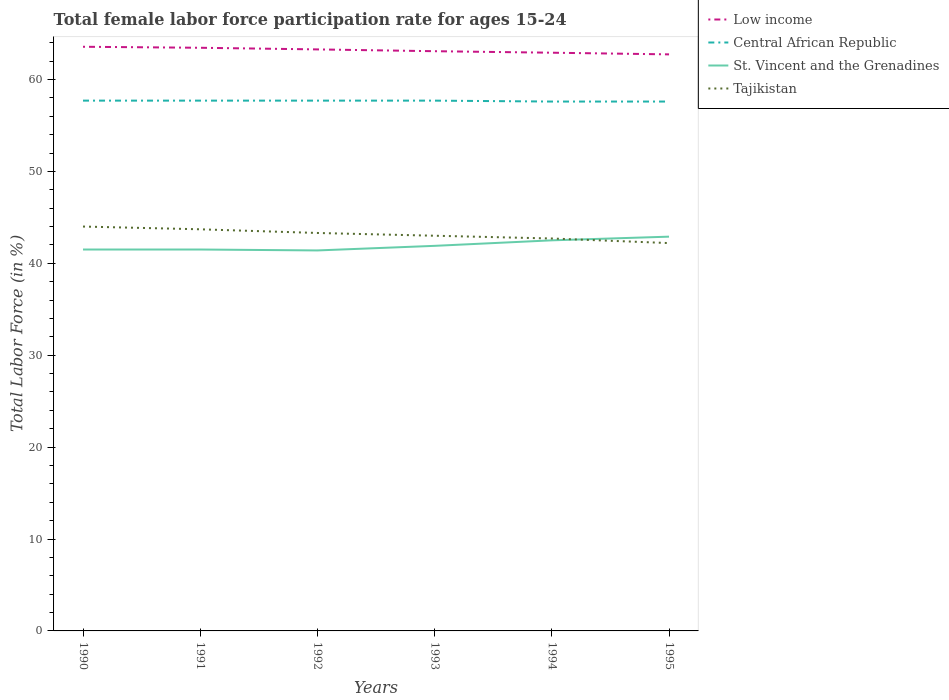How many different coloured lines are there?
Your answer should be compact. 4. Does the line corresponding to Tajikistan intersect with the line corresponding to Central African Republic?
Make the answer very short. No. Is the number of lines equal to the number of legend labels?
Your answer should be compact. Yes. Across all years, what is the maximum female labor force participation rate in Tajikistan?
Offer a terse response. 42.2. What is the difference between the highest and the lowest female labor force participation rate in St. Vincent and the Grenadines?
Provide a succinct answer. 2. Is the female labor force participation rate in St. Vincent and the Grenadines strictly greater than the female labor force participation rate in Tajikistan over the years?
Your answer should be compact. No. How many lines are there?
Offer a terse response. 4. How many years are there in the graph?
Make the answer very short. 6. What is the difference between two consecutive major ticks on the Y-axis?
Your response must be concise. 10. How are the legend labels stacked?
Your response must be concise. Vertical. What is the title of the graph?
Offer a terse response. Total female labor force participation rate for ages 15-24. What is the label or title of the Y-axis?
Ensure brevity in your answer.  Total Labor Force (in %). What is the Total Labor Force (in %) in Low income in 1990?
Your answer should be compact. 63.56. What is the Total Labor Force (in %) in Central African Republic in 1990?
Your answer should be very brief. 57.7. What is the Total Labor Force (in %) of St. Vincent and the Grenadines in 1990?
Offer a terse response. 41.5. What is the Total Labor Force (in %) of Tajikistan in 1990?
Offer a very short reply. 44. What is the Total Labor Force (in %) in Low income in 1991?
Ensure brevity in your answer.  63.45. What is the Total Labor Force (in %) in Central African Republic in 1991?
Ensure brevity in your answer.  57.7. What is the Total Labor Force (in %) of St. Vincent and the Grenadines in 1991?
Your answer should be very brief. 41.5. What is the Total Labor Force (in %) of Tajikistan in 1991?
Ensure brevity in your answer.  43.7. What is the Total Labor Force (in %) in Low income in 1992?
Offer a terse response. 63.27. What is the Total Labor Force (in %) of Central African Republic in 1992?
Make the answer very short. 57.7. What is the Total Labor Force (in %) in St. Vincent and the Grenadines in 1992?
Your answer should be compact. 41.4. What is the Total Labor Force (in %) of Tajikistan in 1992?
Keep it short and to the point. 43.3. What is the Total Labor Force (in %) in Low income in 1993?
Keep it short and to the point. 63.08. What is the Total Labor Force (in %) in Central African Republic in 1993?
Keep it short and to the point. 57.7. What is the Total Labor Force (in %) of St. Vincent and the Grenadines in 1993?
Your answer should be compact. 41.9. What is the Total Labor Force (in %) in Low income in 1994?
Provide a succinct answer. 62.91. What is the Total Labor Force (in %) of Central African Republic in 1994?
Keep it short and to the point. 57.6. What is the Total Labor Force (in %) of St. Vincent and the Grenadines in 1994?
Your answer should be compact. 42.5. What is the Total Labor Force (in %) of Tajikistan in 1994?
Keep it short and to the point. 42.7. What is the Total Labor Force (in %) of Low income in 1995?
Your answer should be very brief. 62.73. What is the Total Labor Force (in %) of Central African Republic in 1995?
Offer a very short reply. 57.6. What is the Total Labor Force (in %) of St. Vincent and the Grenadines in 1995?
Your answer should be very brief. 42.9. What is the Total Labor Force (in %) in Tajikistan in 1995?
Keep it short and to the point. 42.2. Across all years, what is the maximum Total Labor Force (in %) of Low income?
Provide a succinct answer. 63.56. Across all years, what is the maximum Total Labor Force (in %) of Central African Republic?
Provide a succinct answer. 57.7. Across all years, what is the maximum Total Labor Force (in %) in St. Vincent and the Grenadines?
Your answer should be very brief. 42.9. Across all years, what is the maximum Total Labor Force (in %) in Tajikistan?
Offer a very short reply. 44. Across all years, what is the minimum Total Labor Force (in %) of Low income?
Provide a succinct answer. 62.73. Across all years, what is the minimum Total Labor Force (in %) of Central African Republic?
Ensure brevity in your answer.  57.6. Across all years, what is the minimum Total Labor Force (in %) of St. Vincent and the Grenadines?
Offer a terse response. 41.4. Across all years, what is the minimum Total Labor Force (in %) of Tajikistan?
Make the answer very short. 42.2. What is the total Total Labor Force (in %) of Low income in the graph?
Your answer should be compact. 379.01. What is the total Total Labor Force (in %) of Central African Republic in the graph?
Your answer should be very brief. 346. What is the total Total Labor Force (in %) in St. Vincent and the Grenadines in the graph?
Your answer should be compact. 251.7. What is the total Total Labor Force (in %) of Tajikistan in the graph?
Provide a succinct answer. 258.9. What is the difference between the Total Labor Force (in %) in Low income in 1990 and that in 1991?
Give a very brief answer. 0.11. What is the difference between the Total Labor Force (in %) in St. Vincent and the Grenadines in 1990 and that in 1991?
Ensure brevity in your answer.  0. What is the difference between the Total Labor Force (in %) in Tajikistan in 1990 and that in 1991?
Provide a short and direct response. 0.3. What is the difference between the Total Labor Force (in %) in Low income in 1990 and that in 1992?
Keep it short and to the point. 0.29. What is the difference between the Total Labor Force (in %) of Central African Republic in 1990 and that in 1992?
Your answer should be very brief. 0. What is the difference between the Total Labor Force (in %) in Low income in 1990 and that in 1993?
Keep it short and to the point. 0.48. What is the difference between the Total Labor Force (in %) of Tajikistan in 1990 and that in 1993?
Provide a succinct answer. 1. What is the difference between the Total Labor Force (in %) in Low income in 1990 and that in 1994?
Your answer should be compact. 0.65. What is the difference between the Total Labor Force (in %) of St. Vincent and the Grenadines in 1990 and that in 1994?
Offer a terse response. -1. What is the difference between the Total Labor Force (in %) of Tajikistan in 1990 and that in 1994?
Your answer should be compact. 1.3. What is the difference between the Total Labor Force (in %) in Low income in 1990 and that in 1995?
Ensure brevity in your answer.  0.83. What is the difference between the Total Labor Force (in %) of Central African Republic in 1990 and that in 1995?
Offer a very short reply. 0.1. What is the difference between the Total Labor Force (in %) in St. Vincent and the Grenadines in 1990 and that in 1995?
Give a very brief answer. -1.4. What is the difference between the Total Labor Force (in %) in Low income in 1991 and that in 1992?
Your answer should be compact. 0.18. What is the difference between the Total Labor Force (in %) of Central African Republic in 1991 and that in 1992?
Your answer should be compact. 0. What is the difference between the Total Labor Force (in %) of St. Vincent and the Grenadines in 1991 and that in 1992?
Give a very brief answer. 0.1. What is the difference between the Total Labor Force (in %) in Tajikistan in 1991 and that in 1992?
Provide a short and direct response. 0.4. What is the difference between the Total Labor Force (in %) in Low income in 1991 and that in 1993?
Ensure brevity in your answer.  0.37. What is the difference between the Total Labor Force (in %) in Low income in 1991 and that in 1994?
Make the answer very short. 0.54. What is the difference between the Total Labor Force (in %) in Tajikistan in 1991 and that in 1994?
Keep it short and to the point. 1. What is the difference between the Total Labor Force (in %) in Low income in 1991 and that in 1995?
Ensure brevity in your answer.  0.72. What is the difference between the Total Labor Force (in %) in Central African Republic in 1991 and that in 1995?
Provide a succinct answer. 0.1. What is the difference between the Total Labor Force (in %) of Low income in 1992 and that in 1993?
Offer a terse response. 0.2. What is the difference between the Total Labor Force (in %) of Central African Republic in 1992 and that in 1993?
Keep it short and to the point. 0. What is the difference between the Total Labor Force (in %) of Low income in 1992 and that in 1994?
Your response must be concise. 0.36. What is the difference between the Total Labor Force (in %) in Central African Republic in 1992 and that in 1994?
Offer a very short reply. 0.1. What is the difference between the Total Labor Force (in %) in St. Vincent and the Grenadines in 1992 and that in 1994?
Provide a short and direct response. -1.1. What is the difference between the Total Labor Force (in %) in Tajikistan in 1992 and that in 1994?
Ensure brevity in your answer.  0.6. What is the difference between the Total Labor Force (in %) of Low income in 1992 and that in 1995?
Ensure brevity in your answer.  0.54. What is the difference between the Total Labor Force (in %) of St. Vincent and the Grenadines in 1992 and that in 1995?
Make the answer very short. -1.5. What is the difference between the Total Labor Force (in %) in Tajikistan in 1992 and that in 1995?
Ensure brevity in your answer.  1.1. What is the difference between the Total Labor Force (in %) in Low income in 1993 and that in 1994?
Keep it short and to the point. 0.16. What is the difference between the Total Labor Force (in %) in Central African Republic in 1993 and that in 1994?
Your response must be concise. 0.1. What is the difference between the Total Labor Force (in %) in St. Vincent and the Grenadines in 1993 and that in 1994?
Offer a terse response. -0.6. What is the difference between the Total Labor Force (in %) of Low income in 1993 and that in 1995?
Keep it short and to the point. 0.34. What is the difference between the Total Labor Force (in %) in Tajikistan in 1993 and that in 1995?
Offer a terse response. 0.8. What is the difference between the Total Labor Force (in %) of Low income in 1994 and that in 1995?
Provide a succinct answer. 0.18. What is the difference between the Total Labor Force (in %) of St. Vincent and the Grenadines in 1994 and that in 1995?
Keep it short and to the point. -0.4. What is the difference between the Total Labor Force (in %) in Low income in 1990 and the Total Labor Force (in %) in Central African Republic in 1991?
Keep it short and to the point. 5.86. What is the difference between the Total Labor Force (in %) in Low income in 1990 and the Total Labor Force (in %) in St. Vincent and the Grenadines in 1991?
Offer a terse response. 22.06. What is the difference between the Total Labor Force (in %) in Low income in 1990 and the Total Labor Force (in %) in Tajikistan in 1991?
Offer a terse response. 19.86. What is the difference between the Total Labor Force (in %) of Central African Republic in 1990 and the Total Labor Force (in %) of St. Vincent and the Grenadines in 1991?
Offer a terse response. 16.2. What is the difference between the Total Labor Force (in %) of Central African Republic in 1990 and the Total Labor Force (in %) of Tajikistan in 1991?
Offer a terse response. 14. What is the difference between the Total Labor Force (in %) in St. Vincent and the Grenadines in 1990 and the Total Labor Force (in %) in Tajikistan in 1991?
Ensure brevity in your answer.  -2.2. What is the difference between the Total Labor Force (in %) in Low income in 1990 and the Total Labor Force (in %) in Central African Republic in 1992?
Your response must be concise. 5.86. What is the difference between the Total Labor Force (in %) in Low income in 1990 and the Total Labor Force (in %) in St. Vincent and the Grenadines in 1992?
Keep it short and to the point. 22.16. What is the difference between the Total Labor Force (in %) in Low income in 1990 and the Total Labor Force (in %) in Tajikistan in 1992?
Your response must be concise. 20.26. What is the difference between the Total Labor Force (in %) of Central African Republic in 1990 and the Total Labor Force (in %) of Tajikistan in 1992?
Offer a terse response. 14.4. What is the difference between the Total Labor Force (in %) of Low income in 1990 and the Total Labor Force (in %) of Central African Republic in 1993?
Your answer should be very brief. 5.86. What is the difference between the Total Labor Force (in %) of Low income in 1990 and the Total Labor Force (in %) of St. Vincent and the Grenadines in 1993?
Offer a very short reply. 21.66. What is the difference between the Total Labor Force (in %) of Low income in 1990 and the Total Labor Force (in %) of Tajikistan in 1993?
Provide a succinct answer. 20.56. What is the difference between the Total Labor Force (in %) in Central African Republic in 1990 and the Total Labor Force (in %) in Tajikistan in 1993?
Make the answer very short. 14.7. What is the difference between the Total Labor Force (in %) in Low income in 1990 and the Total Labor Force (in %) in Central African Republic in 1994?
Your response must be concise. 5.96. What is the difference between the Total Labor Force (in %) of Low income in 1990 and the Total Labor Force (in %) of St. Vincent and the Grenadines in 1994?
Provide a short and direct response. 21.06. What is the difference between the Total Labor Force (in %) of Low income in 1990 and the Total Labor Force (in %) of Tajikistan in 1994?
Keep it short and to the point. 20.86. What is the difference between the Total Labor Force (in %) in Central African Republic in 1990 and the Total Labor Force (in %) in St. Vincent and the Grenadines in 1994?
Ensure brevity in your answer.  15.2. What is the difference between the Total Labor Force (in %) in Low income in 1990 and the Total Labor Force (in %) in Central African Republic in 1995?
Give a very brief answer. 5.96. What is the difference between the Total Labor Force (in %) in Low income in 1990 and the Total Labor Force (in %) in St. Vincent and the Grenadines in 1995?
Give a very brief answer. 20.66. What is the difference between the Total Labor Force (in %) of Low income in 1990 and the Total Labor Force (in %) of Tajikistan in 1995?
Your response must be concise. 21.36. What is the difference between the Total Labor Force (in %) in Central African Republic in 1990 and the Total Labor Force (in %) in Tajikistan in 1995?
Offer a terse response. 15.5. What is the difference between the Total Labor Force (in %) of St. Vincent and the Grenadines in 1990 and the Total Labor Force (in %) of Tajikistan in 1995?
Provide a succinct answer. -0.7. What is the difference between the Total Labor Force (in %) of Low income in 1991 and the Total Labor Force (in %) of Central African Republic in 1992?
Offer a very short reply. 5.75. What is the difference between the Total Labor Force (in %) of Low income in 1991 and the Total Labor Force (in %) of St. Vincent and the Grenadines in 1992?
Your answer should be compact. 22.05. What is the difference between the Total Labor Force (in %) in Low income in 1991 and the Total Labor Force (in %) in Tajikistan in 1992?
Make the answer very short. 20.15. What is the difference between the Total Labor Force (in %) in Central African Republic in 1991 and the Total Labor Force (in %) in St. Vincent and the Grenadines in 1992?
Provide a succinct answer. 16.3. What is the difference between the Total Labor Force (in %) of Low income in 1991 and the Total Labor Force (in %) of Central African Republic in 1993?
Keep it short and to the point. 5.75. What is the difference between the Total Labor Force (in %) of Low income in 1991 and the Total Labor Force (in %) of St. Vincent and the Grenadines in 1993?
Provide a short and direct response. 21.55. What is the difference between the Total Labor Force (in %) in Low income in 1991 and the Total Labor Force (in %) in Tajikistan in 1993?
Your answer should be very brief. 20.45. What is the difference between the Total Labor Force (in %) in Central African Republic in 1991 and the Total Labor Force (in %) in Tajikistan in 1993?
Give a very brief answer. 14.7. What is the difference between the Total Labor Force (in %) in Low income in 1991 and the Total Labor Force (in %) in Central African Republic in 1994?
Your answer should be compact. 5.85. What is the difference between the Total Labor Force (in %) in Low income in 1991 and the Total Labor Force (in %) in St. Vincent and the Grenadines in 1994?
Offer a very short reply. 20.95. What is the difference between the Total Labor Force (in %) in Low income in 1991 and the Total Labor Force (in %) in Tajikistan in 1994?
Your answer should be compact. 20.75. What is the difference between the Total Labor Force (in %) of Central African Republic in 1991 and the Total Labor Force (in %) of St. Vincent and the Grenadines in 1994?
Ensure brevity in your answer.  15.2. What is the difference between the Total Labor Force (in %) in Central African Republic in 1991 and the Total Labor Force (in %) in Tajikistan in 1994?
Offer a very short reply. 15. What is the difference between the Total Labor Force (in %) of St. Vincent and the Grenadines in 1991 and the Total Labor Force (in %) of Tajikistan in 1994?
Keep it short and to the point. -1.2. What is the difference between the Total Labor Force (in %) in Low income in 1991 and the Total Labor Force (in %) in Central African Republic in 1995?
Provide a succinct answer. 5.85. What is the difference between the Total Labor Force (in %) in Low income in 1991 and the Total Labor Force (in %) in St. Vincent and the Grenadines in 1995?
Give a very brief answer. 20.55. What is the difference between the Total Labor Force (in %) of Low income in 1991 and the Total Labor Force (in %) of Tajikistan in 1995?
Make the answer very short. 21.25. What is the difference between the Total Labor Force (in %) in Central African Republic in 1991 and the Total Labor Force (in %) in St. Vincent and the Grenadines in 1995?
Give a very brief answer. 14.8. What is the difference between the Total Labor Force (in %) of St. Vincent and the Grenadines in 1991 and the Total Labor Force (in %) of Tajikistan in 1995?
Offer a terse response. -0.7. What is the difference between the Total Labor Force (in %) of Low income in 1992 and the Total Labor Force (in %) of Central African Republic in 1993?
Provide a short and direct response. 5.57. What is the difference between the Total Labor Force (in %) of Low income in 1992 and the Total Labor Force (in %) of St. Vincent and the Grenadines in 1993?
Your response must be concise. 21.37. What is the difference between the Total Labor Force (in %) in Low income in 1992 and the Total Labor Force (in %) in Tajikistan in 1993?
Your answer should be compact. 20.27. What is the difference between the Total Labor Force (in %) in Low income in 1992 and the Total Labor Force (in %) in Central African Republic in 1994?
Provide a succinct answer. 5.67. What is the difference between the Total Labor Force (in %) in Low income in 1992 and the Total Labor Force (in %) in St. Vincent and the Grenadines in 1994?
Provide a succinct answer. 20.77. What is the difference between the Total Labor Force (in %) in Low income in 1992 and the Total Labor Force (in %) in Tajikistan in 1994?
Give a very brief answer. 20.57. What is the difference between the Total Labor Force (in %) of Low income in 1992 and the Total Labor Force (in %) of Central African Republic in 1995?
Provide a succinct answer. 5.67. What is the difference between the Total Labor Force (in %) of Low income in 1992 and the Total Labor Force (in %) of St. Vincent and the Grenadines in 1995?
Provide a short and direct response. 20.37. What is the difference between the Total Labor Force (in %) of Low income in 1992 and the Total Labor Force (in %) of Tajikistan in 1995?
Ensure brevity in your answer.  21.07. What is the difference between the Total Labor Force (in %) in Central African Republic in 1992 and the Total Labor Force (in %) in St. Vincent and the Grenadines in 1995?
Make the answer very short. 14.8. What is the difference between the Total Labor Force (in %) of Central African Republic in 1992 and the Total Labor Force (in %) of Tajikistan in 1995?
Offer a terse response. 15.5. What is the difference between the Total Labor Force (in %) in Low income in 1993 and the Total Labor Force (in %) in Central African Republic in 1994?
Keep it short and to the point. 5.48. What is the difference between the Total Labor Force (in %) in Low income in 1993 and the Total Labor Force (in %) in St. Vincent and the Grenadines in 1994?
Offer a very short reply. 20.58. What is the difference between the Total Labor Force (in %) of Low income in 1993 and the Total Labor Force (in %) of Tajikistan in 1994?
Provide a succinct answer. 20.38. What is the difference between the Total Labor Force (in %) in St. Vincent and the Grenadines in 1993 and the Total Labor Force (in %) in Tajikistan in 1994?
Provide a short and direct response. -0.8. What is the difference between the Total Labor Force (in %) in Low income in 1993 and the Total Labor Force (in %) in Central African Republic in 1995?
Make the answer very short. 5.48. What is the difference between the Total Labor Force (in %) of Low income in 1993 and the Total Labor Force (in %) of St. Vincent and the Grenadines in 1995?
Your answer should be very brief. 20.18. What is the difference between the Total Labor Force (in %) of Low income in 1993 and the Total Labor Force (in %) of Tajikistan in 1995?
Offer a terse response. 20.88. What is the difference between the Total Labor Force (in %) of Central African Republic in 1993 and the Total Labor Force (in %) of St. Vincent and the Grenadines in 1995?
Provide a succinct answer. 14.8. What is the difference between the Total Labor Force (in %) of Central African Republic in 1993 and the Total Labor Force (in %) of Tajikistan in 1995?
Give a very brief answer. 15.5. What is the difference between the Total Labor Force (in %) in Low income in 1994 and the Total Labor Force (in %) in Central African Republic in 1995?
Your answer should be very brief. 5.31. What is the difference between the Total Labor Force (in %) in Low income in 1994 and the Total Labor Force (in %) in St. Vincent and the Grenadines in 1995?
Offer a very short reply. 20.01. What is the difference between the Total Labor Force (in %) in Low income in 1994 and the Total Labor Force (in %) in Tajikistan in 1995?
Keep it short and to the point. 20.71. What is the difference between the Total Labor Force (in %) in Central African Republic in 1994 and the Total Labor Force (in %) in St. Vincent and the Grenadines in 1995?
Offer a very short reply. 14.7. What is the difference between the Total Labor Force (in %) in St. Vincent and the Grenadines in 1994 and the Total Labor Force (in %) in Tajikistan in 1995?
Ensure brevity in your answer.  0.3. What is the average Total Labor Force (in %) of Low income per year?
Your answer should be very brief. 63.17. What is the average Total Labor Force (in %) of Central African Republic per year?
Give a very brief answer. 57.67. What is the average Total Labor Force (in %) of St. Vincent and the Grenadines per year?
Your response must be concise. 41.95. What is the average Total Labor Force (in %) of Tajikistan per year?
Your answer should be very brief. 43.15. In the year 1990, what is the difference between the Total Labor Force (in %) of Low income and Total Labor Force (in %) of Central African Republic?
Offer a very short reply. 5.86. In the year 1990, what is the difference between the Total Labor Force (in %) in Low income and Total Labor Force (in %) in St. Vincent and the Grenadines?
Ensure brevity in your answer.  22.06. In the year 1990, what is the difference between the Total Labor Force (in %) in Low income and Total Labor Force (in %) in Tajikistan?
Provide a succinct answer. 19.56. In the year 1990, what is the difference between the Total Labor Force (in %) of Central African Republic and Total Labor Force (in %) of St. Vincent and the Grenadines?
Your answer should be very brief. 16.2. In the year 1990, what is the difference between the Total Labor Force (in %) in St. Vincent and the Grenadines and Total Labor Force (in %) in Tajikistan?
Your answer should be compact. -2.5. In the year 1991, what is the difference between the Total Labor Force (in %) of Low income and Total Labor Force (in %) of Central African Republic?
Offer a terse response. 5.75. In the year 1991, what is the difference between the Total Labor Force (in %) in Low income and Total Labor Force (in %) in St. Vincent and the Grenadines?
Give a very brief answer. 21.95. In the year 1991, what is the difference between the Total Labor Force (in %) in Low income and Total Labor Force (in %) in Tajikistan?
Make the answer very short. 19.75. In the year 1991, what is the difference between the Total Labor Force (in %) in Central African Republic and Total Labor Force (in %) in Tajikistan?
Ensure brevity in your answer.  14. In the year 1991, what is the difference between the Total Labor Force (in %) in St. Vincent and the Grenadines and Total Labor Force (in %) in Tajikistan?
Provide a succinct answer. -2.2. In the year 1992, what is the difference between the Total Labor Force (in %) in Low income and Total Labor Force (in %) in Central African Republic?
Make the answer very short. 5.57. In the year 1992, what is the difference between the Total Labor Force (in %) of Low income and Total Labor Force (in %) of St. Vincent and the Grenadines?
Make the answer very short. 21.87. In the year 1992, what is the difference between the Total Labor Force (in %) in Low income and Total Labor Force (in %) in Tajikistan?
Provide a short and direct response. 19.97. In the year 1992, what is the difference between the Total Labor Force (in %) in Central African Republic and Total Labor Force (in %) in St. Vincent and the Grenadines?
Ensure brevity in your answer.  16.3. In the year 1993, what is the difference between the Total Labor Force (in %) of Low income and Total Labor Force (in %) of Central African Republic?
Your response must be concise. 5.38. In the year 1993, what is the difference between the Total Labor Force (in %) of Low income and Total Labor Force (in %) of St. Vincent and the Grenadines?
Keep it short and to the point. 21.18. In the year 1993, what is the difference between the Total Labor Force (in %) in Low income and Total Labor Force (in %) in Tajikistan?
Provide a succinct answer. 20.08. In the year 1993, what is the difference between the Total Labor Force (in %) in Central African Republic and Total Labor Force (in %) in St. Vincent and the Grenadines?
Offer a very short reply. 15.8. In the year 1993, what is the difference between the Total Labor Force (in %) of St. Vincent and the Grenadines and Total Labor Force (in %) of Tajikistan?
Your answer should be compact. -1.1. In the year 1994, what is the difference between the Total Labor Force (in %) in Low income and Total Labor Force (in %) in Central African Republic?
Make the answer very short. 5.31. In the year 1994, what is the difference between the Total Labor Force (in %) in Low income and Total Labor Force (in %) in St. Vincent and the Grenadines?
Offer a terse response. 20.41. In the year 1994, what is the difference between the Total Labor Force (in %) in Low income and Total Labor Force (in %) in Tajikistan?
Your answer should be compact. 20.21. In the year 1994, what is the difference between the Total Labor Force (in %) in Central African Republic and Total Labor Force (in %) in Tajikistan?
Offer a very short reply. 14.9. In the year 1995, what is the difference between the Total Labor Force (in %) of Low income and Total Labor Force (in %) of Central African Republic?
Keep it short and to the point. 5.13. In the year 1995, what is the difference between the Total Labor Force (in %) of Low income and Total Labor Force (in %) of St. Vincent and the Grenadines?
Ensure brevity in your answer.  19.83. In the year 1995, what is the difference between the Total Labor Force (in %) of Low income and Total Labor Force (in %) of Tajikistan?
Offer a very short reply. 20.53. In the year 1995, what is the difference between the Total Labor Force (in %) in Central African Republic and Total Labor Force (in %) in St. Vincent and the Grenadines?
Your answer should be very brief. 14.7. In the year 1995, what is the difference between the Total Labor Force (in %) in Central African Republic and Total Labor Force (in %) in Tajikistan?
Give a very brief answer. 15.4. In the year 1995, what is the difference between the Total Labor Force (in %) of St. Vincent and the Grenadines and Total Labor Force (in %) of Tajikistan?
Your answer should be compact. 0.7. What is the ratio of the Total Labor Force (in %) in Low income in 1990 to that in 1991?
Your response must be concise. 1. What is the ratio of the Total Labor Force (in %) in St. Vincent and the Grenadines in 1990 to that in 1991?
Provide a succinct answer. 1. What is the ratio of the Total Labor Force (in %) in Tajikistan in 1990 to that in 1991?
Offer a terse response. 1.01. What is the ratio of the Total Labor Force (in %) of Low income in 1990 to that in 1992?
Provide a short and direct response. 1. What is the ratio of the Total Labor Force (in %) of Tajikistan in 1990 to that in 1992?
Keep it short and to the point. 1.02. What is the ratio of the Total Labor Force (in %) of Low income in 1990 to that in 1993?
Ensure brevity in your answer.  1.01. What is the ratio of the Total Labor Force (in %) of Central African Republic in 1990 to that in 1993?
Keep it short and to the point. 1. What is the ratio of the Total Labor Force (in %) in Tajikistan in 1990 to that in 1993?
Provide a short and direct response. 1.02. What is the ratio of the Total Labor Force (in %) of Low income in 1990 to that in 1994?
Keep it short and to the point. 1.01. What is the ratio of the Total Labor Force (in %) in St. Vincent and the Grenadines in 1990 to that in 1994?
Offer a very short reply. 0.98. What is the ratio of the Total Labor Force (in %) in Tajikistan in 1990 to that in 1994?
Give a very brief answer. 1.03. What is the ratio of the Total Labor Force (in %) in Low income in 1990 to that in 1995?
Give a very brief answer. 1.01. What is the ratio of the Total Labor Force (in %) of Central African Republic in 1990 to that in 1995?
Keep it short and to the point. 1. What is the ratio of the Total Labor Force (in %) in St. Vincent and the Grenadines in 1990 to that in 1995?
Provide a succinct answer. 0.97. What is the ratio of the Total Labor Force (in %) of Tajikistan in 1990 to that in 1995?
Offer a terse response. 1.04. What is the ratio of the Total Labor Force (in %) of Low income in 1991 to that in 1992?
Make the answer very short. 1. What is the ratio of the Total Labor Force (in %) of Tajikistan in 1991 to that in 1992?
Give a very brief answer. 1.01. What is the ratio of the Total Labor Force (in %) of Low income in 1991 to that in 1993?
Provide a succinct answer. 1.01. What is the ratio of the Total Labor Force (in %) in St. Vincent and the Grenadines in 1991 to that in 1993?
Your answer should be very brief. 0.99. What is the ratio of the Total Labor Force (in %) in Tajikistan in 1991 to that in 1993?
Give a very brief answer. 1.02. What is the ratio of the Total Labor Force (in %) in Low income in 1991 to that in 1994?
Give a very brief answer. 1.01. What is the ratio of the Total Labor Force (in %) in Central African Republic in 1991 to that in 1994?
Ensure brevity in your answer.  1. What is the ratio of the Total Labor Force (in %) in St. Vincent and the Grenadines in 1991 to that in 1994?
Ensure brevity in your answer.  0.98. What is the ratio of the Total Labor Force (in %) in Tajikistan in 1991 to that in 1994?
Keep it short and to the point. 1.02. What is the ratio of the Total Labor Force (in %) in Low income in 1991 to that in 1995?
Keep it short and to the point. 1.01. What is the ratio of the Total Labor Force (in %) in Central African Republic in 1991 to that in 1995?
Give a very brief answer. 1. What is the ratio of the Total Labor Force (in %) of St. Vincent and the Grenadines in 1991 to that in 1995?
Ensure brevity in your answer.  0.97. What is the ratio of the Total Labor Force (in %) of Tajikistan in 1991 to that in 1995?
Keep it short and to the point. 1.04. What is the ratio of the Total Labor Force (in %) of St. Vincent and the Grenadines in 1992 to that in 1993?
Your answer should be compact. 0.99. What is the ratio of the Total Labor Force (in %) in Tajikistan in 1992 to that in 1993?
Your answer should be compact. 1.01. What is the ratio of the Total Labor Force (in %) in Low income in 1992 to that in 1994?
Your answer should be very brief. 1.01. What is the ratio of the Total Labor Force (in %) in Central African Republic in 1992 to that in 1994?
Your answer should be compact. 1. What is the ratio of the Total Labor Force (in %) of St. Vincent and the Grenadines in 1992 to that in 1994?
Give a very brief answer. 0.97. What is the ratio of the Total Labor Force (in %) in Tajikistan in 1992 to that in 1994?
Offer a very short reply. 1.01. What is the ratio of the Total Labor Force (in %) of Low income in 1992 to that in 1995?
Provide a succinct answer. 1.01. What is the ratio of the Total Labor Force (in %) of Central African Republic in 1992 to that in 1995?
Give a very brief answer. 1. What is the ratio of the Total Labor Force (in %) of St. Vincent and the Grenadines in 1992 to that in 1995?
Provide a succinct answer. 0.96. What is the ratio of the Total Labor Force (in %) in Tajikistan in 1992 to that in 1995?
Your answer should be compact. 1.03. What is the ratio of the Total Labor Force (in %) of St. Vincent and the Grenadines in 1993 to that in 1994?
Make the answer very short. 0.99. What is the ratio of the Total Labor Force (in %) of Low income in 1993 to that in 1995?
Your answer should be very brief. 1.01. What is the ratio of the Total Labor Force (in %) of St. Vincent and the Grenadines in 1993 to that in 1995?
Offer a terse response. 0.98. What is the ratio of the Total Labor Force (in %) of Central African Republic in 1994 to that in 1995?
Provide a succinct answer. 1. What is the ratio of the Total Labor Force (in %) of St. Vincent and the Grenadines in 1994 to that in 1995?
Make the answer very short. 0.99. What is the ratio of the Total Labor Force (in %) in Tajikistan in 1994 to that in 1995?
Provide a short and direct response. 1.01. What is the difference between the highest and the second highest Total Labor Force (in %) in Low income?
Offer a very short reply. 0.11. What is the difference between the highest and the second highest Total Labor Force (in %) of Central African Republic?
Make the answer very short. 0. What is the difference between the highest and the second highest Total Labor Force (in %) of Tajikistan?
Make the answer very short. 0.3. What is the difference between the highest and the lowest Total Labor Force (in %) of Low income?
Keep it short and to the point. 0.83. What is the difference between the highest and the lowest Total Labor Force (in %) of Central African Republic?
Your answer should be very brief. 0.1. 